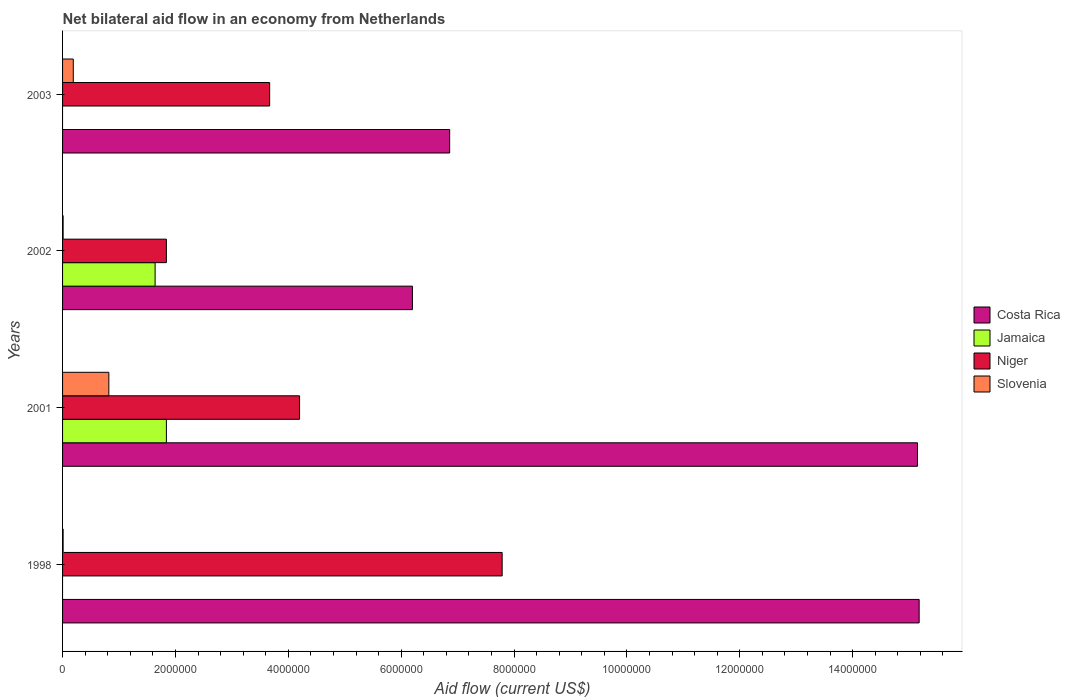In how many cases, is the number of bars for a given year not equal to the number of legend labels?
Make the answer very short. 2. What is the net bilateral aid flow in Jamaica in 2002?
Keep it short and to the point. 1.64e+06. Across all years, what is the maximum net bilateral aid flow in Costa Rica?
Ensure brevity in your answer.  1.52e+07. Across all years, what is the minimum net bilateral aid flow in Niger?
Make the answer very short. 1.84e+06. What is the total net bilateral aid flow in Jamaica in the graph?
Ensure brevity in your answer.  3.48e+06. What is the difference between the net bilateral aid flow in Slovenia in 2001 and that in 2003?
Provide a succinct answer. 6.30e+05. What is the difference between the net bilateral aid flow in Slovenia in 2003 and the net bilateral aid flow in Costa Rica in 2002?
Keep it short and to the point. -6.01e+06. What is the average net bilateral aid flow in Slovenia per year?
Make the answer very short. 2.58e+05. In the year 2001, what is the difference between the net bilateral aid flow in Jamaica and net bilateral aid flow in Niger?
Make the answer very short. -2.36e+06. In how many years, is the net bilateral aid flow in Jamaica greater than 5200000 US$?
Ensure brevity in your answer.  0. What is the ratio of the net bilateral aid flow in Slovenia in 2002 to that in 2003?
Offer a very short reply. 0.05. Is the net bilateral aid flow in Costa Rica in 1998 less than that in 2003?
Make the answer very short. No. What is the difference between the highest and the second highest net bilateral aid flow in Slovenia?
Provide a short and direct response. 6.30e+05. What is the difference between the highest and the lowest net bilateral aid flow in Niger?
Offer a terse response. 5.95e+06. In how many years, is the net bilateral aid flow in Costa Rica greater than the average net bilateral aid flow in Costa Rica taken over all years?
Provide a short and direct response. 2. Is the sum of the net bilateral aid flow in Slovenia in 1998 and 2003 greater than the maximum net bilateral aid flow in Niger across all years?
Ensure brevity in your answer.  No. Is it the case that in every year, the sum of the net bilateral aid flow in Costa Rica and net bilateral aid flow in Slovenia is greater than the net bilateral aid flow in Niger?
Give a very brief answer. Yes. Are all the bars in the graph horizontal?
Provide a short and direct response. Yes. How many years are there in the graph?
Ensure brevity in your answer.  4. What is the difference between two consecutive major ticks on the X-axis?
Ensure brevity in your answer.  2.00e+06. Are the values on the major ticks of X-axis written in scientific E-notation?
Your answer should be compact. No. How many legend labels are there?
Offer a terse response. 4. How are the legend labels stacked?
Provide a succinct answer. Vertical. What is the title of the graph?
Make the answer very short. Net bilateral aid flow in an economy from Netherlands. Does "Switzerland" appear as one of the legend labels in the graph?
Make the answer very short. No. What is the label or title of the Y-axis?
Give a very brief answer. Years. What is the Aid flow (current US$) in Costa Rica in 1998?
Offer a terse response. 1.52e+07. What is the Aid flow (current US$) in Jamaica in 1998?
Give a very brief answer. 0. What is the Aid flow (current US$) in Niger in 1998?
Your answer should be very brief. 7.79e+06. What is the Aid flow (current US$) in Slovenia in 1998?
Make the answer very short. 10000. What is the Aid flow (current US$) of Costa Rica in 2001?
Offer a very short reply. 1.52e+07. What is the Aid flow (current US$) in Jamaica in 2001?
Make the answer very short. 1.84e+06. What is the Aid flow (current US$) in Niger in 2001?
Make the answer very short. 4.20e+06. What is the Aid flow (current US$) in Slovenia in 2001?
Provide a short and direct response. 8.20e+05. What is the Aid flow (current US$) of Costa Rica in 2002?
Make the answer very short. 6.20e+06. What is the Aid flow (current US$) in Jamaica in 2002?
Give a very brief answer. 1.64e+06. What is the Aid flow (current US$) in Niger in 2002?
Ensure brevity in your answer.  1.84e+06. What is the Aid flow (current US$) in Slovenia in 2002?
Ensure brevity in your answer.  10000. What is the Aid flow (current US$) in Costa Rica in 2003?
Your answer should be compact. 6.86e+06. What is the Aid flow (current US$) in Jamaica in 2003?
Give a very brief answer. 0. What is the Aid flow (current US$) of Niger in 2003?
Provide a succinct answer. 3.67e+06. What is the Aid flow (current US$) of Slovenia in 2003?
Give a very brief answer. 1.90e+05. Across all years, what is the maximum Aid flow (current US$) of Costa Rica?
Provide a short and direct response. 1.52e+07. Across all years, what is the maximum Aid flow (current US$) of Jamaica?
Offer a terse response. 1.84e+06. Across all years, what is the maximum Aid flow (current US$) in Niger?
Offer a very short reply. 7.79e+06. Across all years, what is the maximum Aid flow (current US$) in Slovenia?
Your answer should be compact. 8.20e+05. Across all years, what is the minimum Aid flow (current US$) of Costa Rica?
Provide a succinct answer. 6.20e+06. Across all years, what is the minimum Aid flow (current US$) in Niger?
Keep it short and to the point. 1.84e+06. Across all years, what is the minimum Aid flow (current US$) in Slovenia?
Your response must be concise. 10000. What is the total Aid flow (current US$) of Costa Rica in the graph?
Offer a terse response. 4.34e+07. What is the total Aid flow (current US$) of Jamaica in the graph?
Offer a terse response. 3.48e+06. What is the total Aid flow (current US$) of Niger in the graph?
Provide a short and direct response. 1.75e+07. What is the total Aid flow (current US$) in Slovenia in the graph?
Offer a terse response. 1.03e+06. What is the difference between the Aid flow (current US$) in Costa Rica in 1998 and that in 2001?
Keep it short and to the point. 3.00e+04. What is the difference between the Aid flow (current US$) of Niger in 1998 and that in 2001?
Ensure brevity in your answer.  3.59e+06. What is the difference between the Aid flow (current US$) of Slovenia in 1998 and that in 2001?
Your response must be concise. -8.10e+05. What is the difference between the Aid flow (current US$) in Costa Rica in 1998 and that in 2002?
Provide a short and direct response. 8.98e+06. What is the difference between the Aid flow (current US$) in Niger in 1998 and that in 2002?
Offer a terse response. 5.95e+06. What is the difference between the Aid flow (current US$) in Costa Rica in 1998 and that in 2003?
Your response must be concise. 8.32e+06. What is the difference between the Aid flow (current US$) in Niger in 1998 and that in 2003?
Provide a short and direct response. 4.12e+06. What is the difference between the Aid flow (current US$) in Costa Rica in 2001 and that in 2002?
Offer a very short reply. 8.95e+06. What is the difference between the Aid flow (current US$) of Niger in 2001 and that in 2002?
Provide a short and direct response. 2.36e+06. What is the difference between the Aid flow (current US$) of Slovenia in 2001 and that in 2002?
Your response must be concise. 8.10e+05. What is the difference between the Aid flow (current US$) of Costa Rica in 2001 and that in 2003?
Your response must be concise. 8.29e+06. What is the difference between the Aid flow (current US$) in Niger in 2001 and that in 2003?
Provide a succinct answer. 5.30e+05. What is the difference between the Aid flow (current US$) of Slovenia in 2001 and that in 2003?
Offer a very short reply. 6.30e+05. What is the difference between the Aid flow (current US$) of Costa Rica in 2002 and that in 2003?
Provide a succinct answer. -6.60e+05. What is the difference between the Aid flow (current US$) in Niger in 2002 and that in 2003?
Keep it short and to the point. -1.83e+06. What is the difference between the Aid flow (current US$) in Slovenia in 2002 and that in 2003?
Your answer should be compact. -1.80e+05. What is the difference between the Aid flow (current US$) of Costa Rica in 1998 and the Aid flow (current US$) of Jamaica in 2001?
Provide a succinct answer. 1.33e+07. What is the difference between the Aid flow (current US$) in Costa Rica in 1998 and the Aid flow (current US$) in Niger in 2001?
Your answer should be very brief. 1.10e+07. What is the difference between the Aid flow (current US$) of Costa Rica in 1998 and the Aid flow (current US$) of Slovenia in 2001?
Your answer should be compact. 1.44e+07. What is the difference between the Aid flow (current US$) of Niger in 1998 and the Aid flow (current US$) of Slovenia in 2001?
Your answer should be compact. 6.97e+06. What is the difference between the Aid flow (current US$) of Costa Rica in 1998 and the Aid flow (current US$) of Jamaica in 2002?
Your answer should be compact. 1.35e+07. What is the difference between the Aid flow (current US$) of Costa Rica in 1998 and the Aid flow (current US$) of Niger in 2002?
Ensure brevity in your answer.  1.33e+07. What is the difference between the Aid flow (current US$) in Costa Rica in 1998 and the Aid flow (current US$) in Slovenia in 2002?
Provide a succinct answer. 1.52e+07. What is the difference between the Aid flow (current US$) of Niger in 1998 and the Aid flow (current US$) of Slovenia in 2002?
Make the answer very short. 7.78e+06. What is the difference between the Aid flow (current US$) of Costa Rica in 1998 and the Aid flow (current US$) of Niger in 2003?
Give a very brief answer. 1.15e+07. What is the difference between the Aid flow (current US$) in Costa Rica in 1998 and the Aid flow (current US$) in Slovenia in 2003?
Provide a short and direct response. 1.50e+07. What is the difference between the Aid flow (current US$) in Niger in 1998 and the Aid flow (current US$) in Slovenia in 2003?
Your answer should be very brief. 7.60e+06. What is the difference between the Aid flow (current US$) of Costa Rica in 2001 and the Aid flow (current US$) of Jamaica in 2002?
Make the answer very short. 1.35e+07. What is the difference between the Aid flow (current US$) of Costa Rica in 2001 and the Aid flow (current US$) of Niger in 2002?
Provide a short and direct response. 1.33e+07. What is the difference between the Aid flow (current US$) in Costa Rica in 2001 and the Aid flow (current US$) in Slovenia in 2002?
Give a very brief answer. 1.51e+07. What is the difference between the Aid flow (current US$) of Jamaica in 2001 and the Aid flow (current US$) of Slovenia in 2002?
Offer a very short reply. 1.83e+06. What is the difference between the Aid flow (current US$) in Niger in 2001 and the Aid flow (current US$) in Slovenia in 2002?
Ensure brevity in your answer.  4.19e+06. What is the difference between the Aid flow (current US$) of Costa Rica in 2001 and the Aid flow (current US$) of Niger in 2003?
Make the answer very short. 1.15e+07. What is the difference between the Aid flow (current US$) in Costa Rica in 2001 and the Aid flow (current US$) in Slovenia in 2003?
Your answer should be compact. 1.50e+07. What is the difference between the Aid flow (current US$) of Jamaica in 2001 and the Aid flow (current US$) of Niger in 2003?
Your answer should be compact. -1.83e+06. What is the difference between the Aid flow (current US$) of Jamaica in 2001 and the Aid flow (current US$) of Slovenia in 2003?
Give a very brief answer. 1.65e+06. What is the difference between the Aid flow (current US$) of Niger in 2001 and the Aid flow (current US$) of Slovenia in 2003?
Provide a short and direct response. 4.01e+06. What is the difference between the Aid flow (current US$) in Costa Rica in 2002 and the Aid flow (current US$) in Niger in 2003?
Your response must be concise. 2.53e+06. What is the difference between the Aid flow (current US$) in Costa Rica in 2002 and the Aid flow (current US$) in Slovenia in 2003?
Ensure brevity in your answer.  6.01e+06. What is the difference between the Aid flow (current US$) in Jamaica in 2002 and the Aid flow (current US$) in Niger in 2003?
Your answer should be compact. -2.03e+06. What is the difference between the Aid flow (current US$) in Jamaica in 2002 and the Aid flow (current US$) in Slovenia in 2003?
Make the answer very short. 1.45e+06. What is the difference between the Aid flow (current US$) of Niger in 2002 and the Aid flow (current US$) of Slovenia in 2003?
Provide a short and direct response. 1.65e+06. What is the average Aid flow (current US$) in Costa Rica per year?
Make the answer very short. 1.08e+07. What is the average Aid flow (current US$) in Jamaica per year?
Offer a very short reply. 8.70e+05. What is the average Aid flow (current US$) in Niger per year?
Your response must be concise. 4.38e+06. What is the average Aid flow (current US$) of Slovenia per year?
Your answer should be compact. 2.58e+05. In the year 1998, what is the difference between the Aid flow (current US$) of Costa Rica and Aid flow (current US$) of Niger?
Give a very brief answer. 7.39e+06. In the year 1998, what is the difference between the Aid flow (current US$) of Costa Rica and Aid flow (current US$) of Slovenia?
Your answer should be compact. 1.52e+07. In the year 1998, what is the difference between the Aid flow (current US$) in Niger and Aid flow (current US$) in Slovenia?
Offer a very short reply. 7.78e+06. In the year 2001, what is the difference between the Aid flow (current US$) of Costa Rica and Aid flow (current US$) of Jamaica?
Keep it short and to the point. 1.33e+07. In the year 2001, what is the difference between the Aid flow (current US$) in Costa Rica and Aid flow (current US$) in Niger?
Offer a terse response. 1.10e+07. In the year 2001, what is the difference between the Aid flow (current US$) of Costa Rica and Aid flow (current US$) of Slovenia?
Your answer should be compact. 1.43e+07. In the year 2001, what is the difference between the Aid flow (current US$) in Jamaica and Aid flow (current US$) in Niger?
Provide a succinct answer. -2.36e+06. In the year 2001, what is the difference between the Aid flow (current US$) in Jamaica and Aid flow (current US$) in Slovenia?
Make the answer very short. 1.02e+06. In the year 2001, what is the difference between the Aid flow (current US$) in Niger and Aid flow (current US$) in Slovenia?
Provide a short and direct response. 3.38e+06. In the year 2002, what is the difference between the Aid flow (current US$) of Costa Rica and Aid flow (current US$) of Jamaica?
Offer a terse response. 4.56e+06. In the year 2002, what is the difference between the Aid flow (current US$) in Costa Rica and Aid flow (current US$) in Niger?
Provide a succinct answer. 4.36e+06. In the year 2002, what is the difference between the Aid flow (current US$) of Costa Rica and Aid flow (current US$) of Slovenia?
Give a very brief answer. 6.19e+06. In the year 2002, what is the difference between the Aid flow (current US$) in Jamaica and Aid flow (current US$) in Niger?
Offer a very short reply. -2.00e+05. In the year 2002, what is the difference between the Aid flow (current US$) of Jamaica and Aid flow (current US$) of Slovenia?
Make the answer very short. 1.63e+06. In the year 2002, what is the difference between the Aid flow (current US$) in Niger and Aid flow (current US$) in Slovenia?
Your response must be concise. 1.83e+06. In the year 2003, what is the difference between the Aid flow (current US$) of Costa Rica and Aid flow (current US$) of Niger?
Offer a terse response. 3.19e+06. In the year 2003, what is the difference between the Aid flow (current US$) in Costa Rica and Aid flow (current US$) in Slovenia?
Keep it short and to the point. 6.67e+06. In the year 2003, what is the difference between the Aid flow (current US$) of Niger and Aid flow (current US$) of Slovenia?
Provide a short and direct response. 3.48e+06. What is the ratio of the Aid flow (current US$) in Niger in 1998 to that in 2001?
Provide a succinct answer. 1.85. What is the ratio of the Aid flow (current US$) in Slovenia in 1998 to that in 2001?
Your response must be concise. 0.01. What is the ratio of the Aid flow (current US$) of Costa Rica in 1998 to that in 2002?
Offer a very short reply. 2.45. What is the ratio of the Aid flow (current US$) of Niger in 1998 to that in 2002?
Make the answer very short. 4.23. What is the ratio of the Aid flow (current US$) in Slovenia in 1998 to that in 2002?
Your response must be concise. 1. What is the ratio of the Aid flow (current US$) in Costa Rica in 1998 to that in 2003?
Your answer should be very brief. 2.21. What is the ratio of the Aid flow (current US$) of Niger in 1998 to that in 2003?
Offer a terse response. 2.12. What is the ratio of the Aid flow (current US$) of Slovenia in 1998 to that in 2003?
Ensure brevity in your answer.  0.05. What is the ratio of the Aid flow (current US$) of Costa Rica in 2001 to that in 2002?
Your answer should be very brief. 2.44. What is the ratio of the Aid flow (current US$) of Jamaica in 2001 to that in 2002?
Make the answer very short. 1.12. What is the ratio of the Aid flow (current US$) in Niger in 2001 to that in 2002?
Ensure brevity in your answer.  2.28. What is the ratio of the Aid flow (current US$) in Slovenia in 2001 to that in 2002?
Your answer should be very brief. 82. What is the ratio of the Aid flow (current US$) of Costa Rica in 2001 to that in 2003?
Keep it short and to the point. 2.21. What is the ratio of the Aid flow (current US$) in Niger in 2001 to that in 2003?
Keep it short and to the point. 1.14. What is the ratio of the Aid flow (current US$) of Slovenia in 2001 to that in 2003?
Give a very brief answer. 4.32. What is the ratio of the Aid flow (current US$) in Costa Rica in 2002 to that in 2003?
Your answer should be compact. 0.9. What is the ratio of the Aid flow (current US$) in Niger in 2002 to that in 2003?
Your response must be concise. 0.5. What is the ratio of the Aid flow (current US$) in Slovenia in 2002 to that in 2003?
Make the answer very short. 0.05. What is the difference between the highest and the second highest Aid flow (current US$) of Costa Rica?
Make the answer very short. 3.00e+04. What is the difference between the highest and the second highest Aid flow (current US$) in Niger?
Keep it short and to the point. 3.59e+06. What is the difference between the highest and the second highest Aid flow (current US$) in Slovenia?
Keep it short and to the point. 6.30e+05. What is the difference between the highest and the lowest Aid flow (current US$) of Costa Rica?
Your response must be concise. 8.98e+06. What is the difference between the highest and the lowest Aid flow (current US$) of Jamaica?
Give a very brief answer. 1.84e+06. What is the difference between the highest and the lowest Aid flow (current US$) of Niger?
Make the answer very short. 5.95e+06. What is the difference between the highest and the lowest Aid flow (current US$) of Slovenia?
Your answer should be compact. 8.10e+05. 